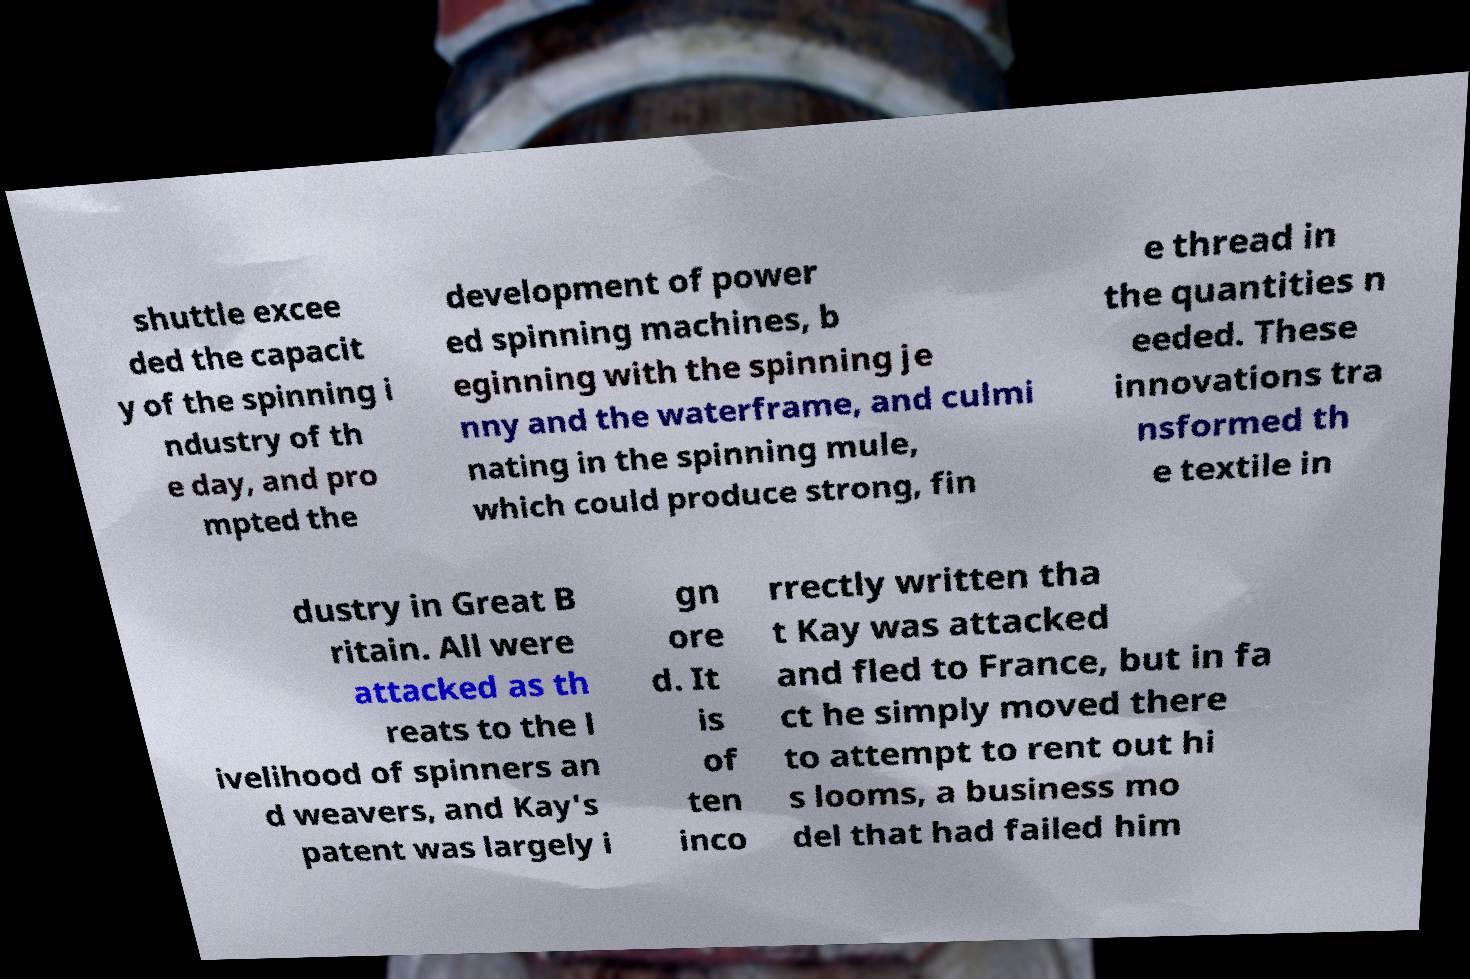Could you extract and type out the text from this image? shuttle excee ded the capacit y of the spinning i ndustry of th e day, and pro mpted the development of power ed spinning machines, b eginning with the spinning je nny and the waterframe, and culmi nating in the spinning mule, which could produce strong, fin e thread in the quantities n eeded. These innovations tra nsformed th e textile in dustry in Great B ritain. All were attacked as th reats to the l ivelihood of spinners an d weavers, and Kay's patent was largely i gn ore d. It is of ten inco rrectly written tha t Kay was attacked and fled to France, but in fa ct he simply moved there to attempt to rent out hi s looms, a business mo del that had failed him 